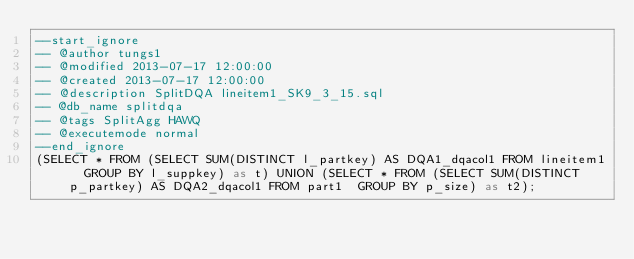Convert code to text. <code><loc_0><loc_0><loc_500><loc_500><_SQL_>--start_ignore
-- @author tungs1
-- @modified 2013-07-17 12:00:00
-- @created 2013-07-17 12:00:00
-- @description SplitDQA lineitem1_SK9_3_15.sql
-- @db_name splitdqa
-- @tags SplitAgg HAWQ
-- @executemode normal
--end_ignore
(SELECT * FROM (SELECT SUM(DISTINCT l_partkey) AS DQA1_dqacol1 FROM lineitem1  GROUP BY l_suppkey) as t) UNION (SELECT * FROM (SELECT SUM(DISTINCT p_partkey) AS DQA2_dqacol1 FROM part1  GROUP BY p_size) as t2);
</code> 